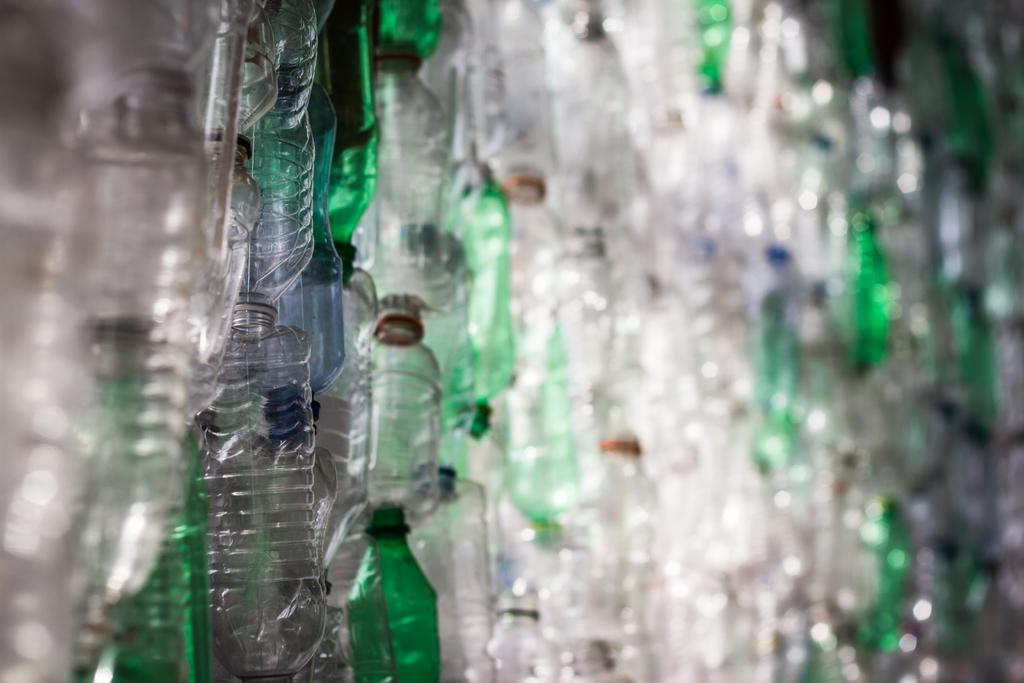What objects can be seen in the image? There are bottles in the image. How many spiders are crawling on the crown in the image? There is no crown or spiders present in the image; it only features bottles. 